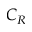Convert formula to latex. <formula><loc_0><loc_0><loc_500><loc_500>C _ { R }</formula> 